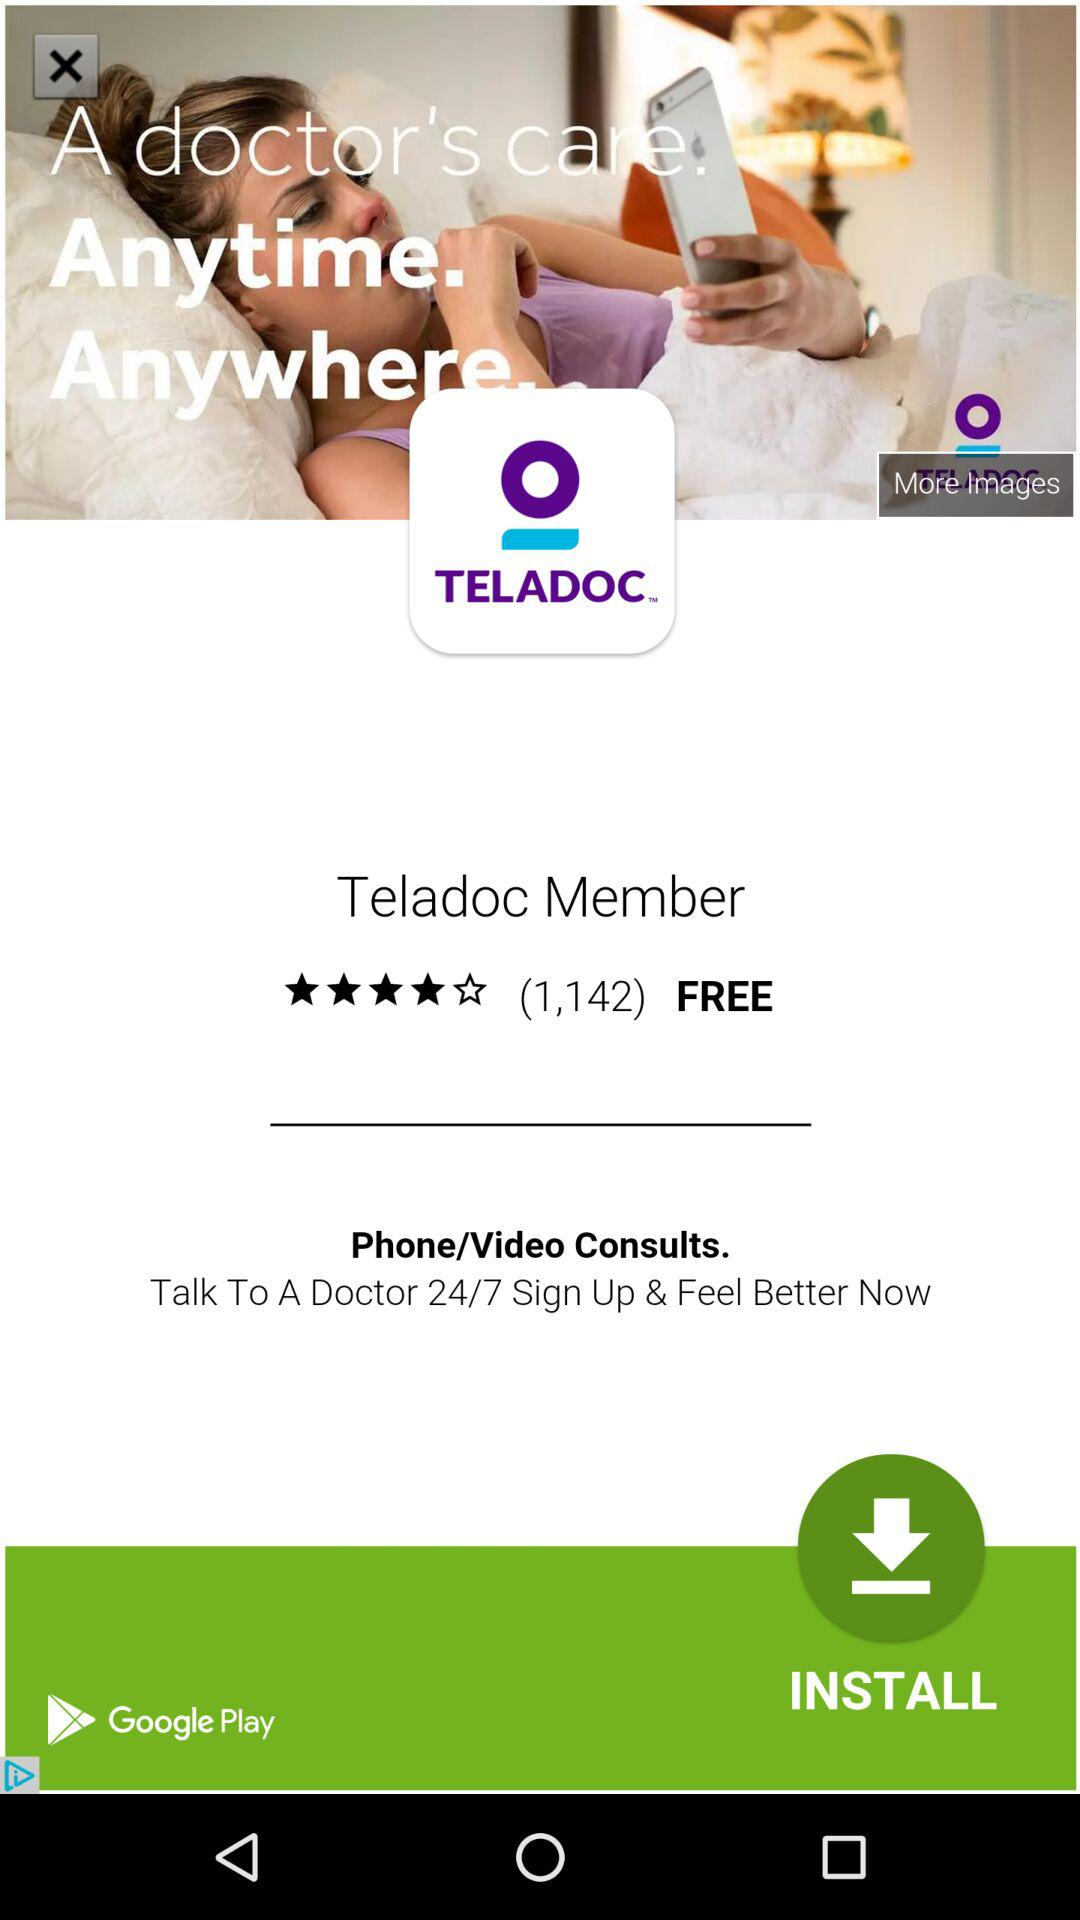How many people are using this?
When the provided information is insufficient, respond with <no answer>. <no answer> 